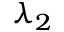<formula> <loc_0><loc_0><loc_500><loc_500>\lambda _ { 2 }</formula> 